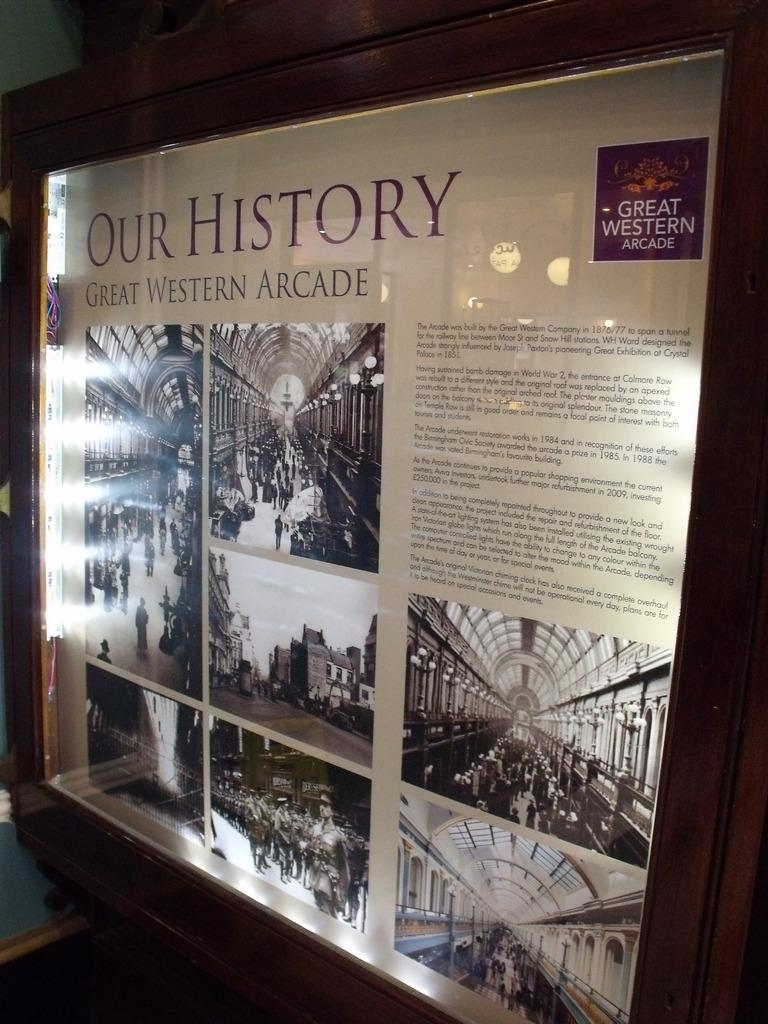<image>
Summarize the visual content of the image. A large poster about our history in a glass case. 